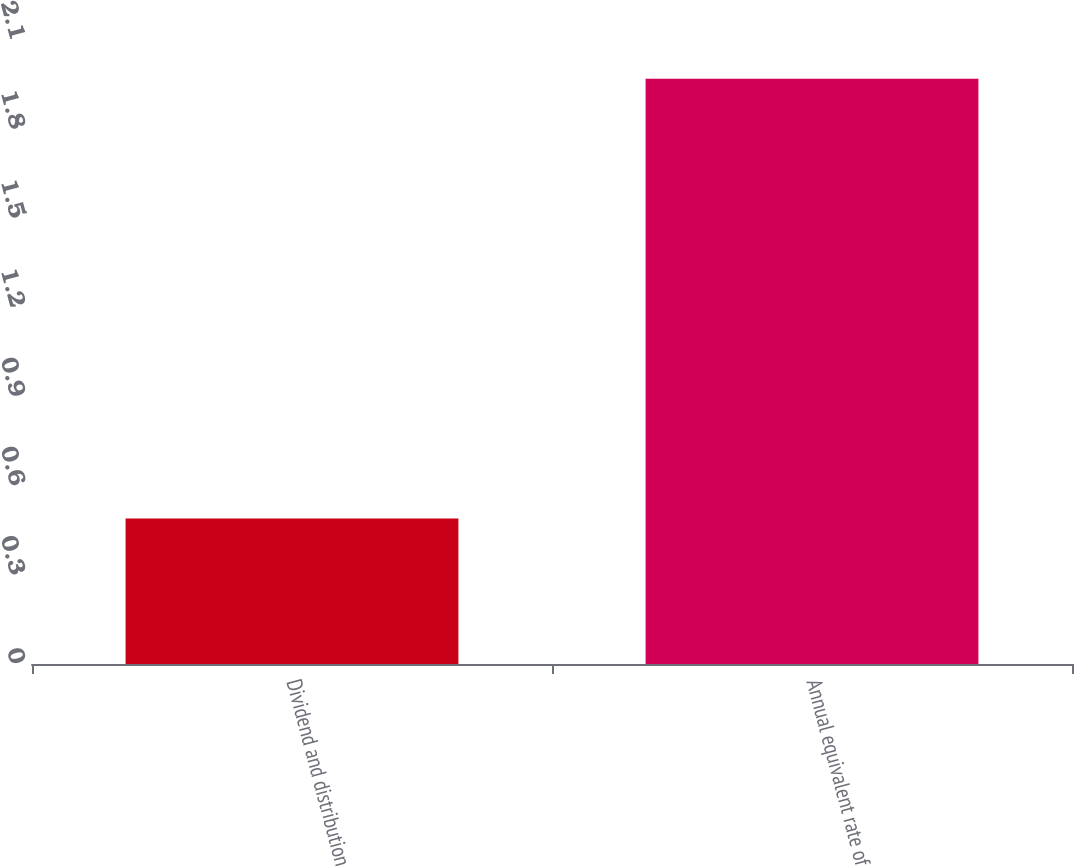Convert chart to OTSL. <chart><loc_0><loc_0><loc_500><loc_500><bar_chart><fcel>Dividend and distribution<fcel>Annual equivalent rate of<nl><fcel>0.49<fcel>1.97<nl></chart> 